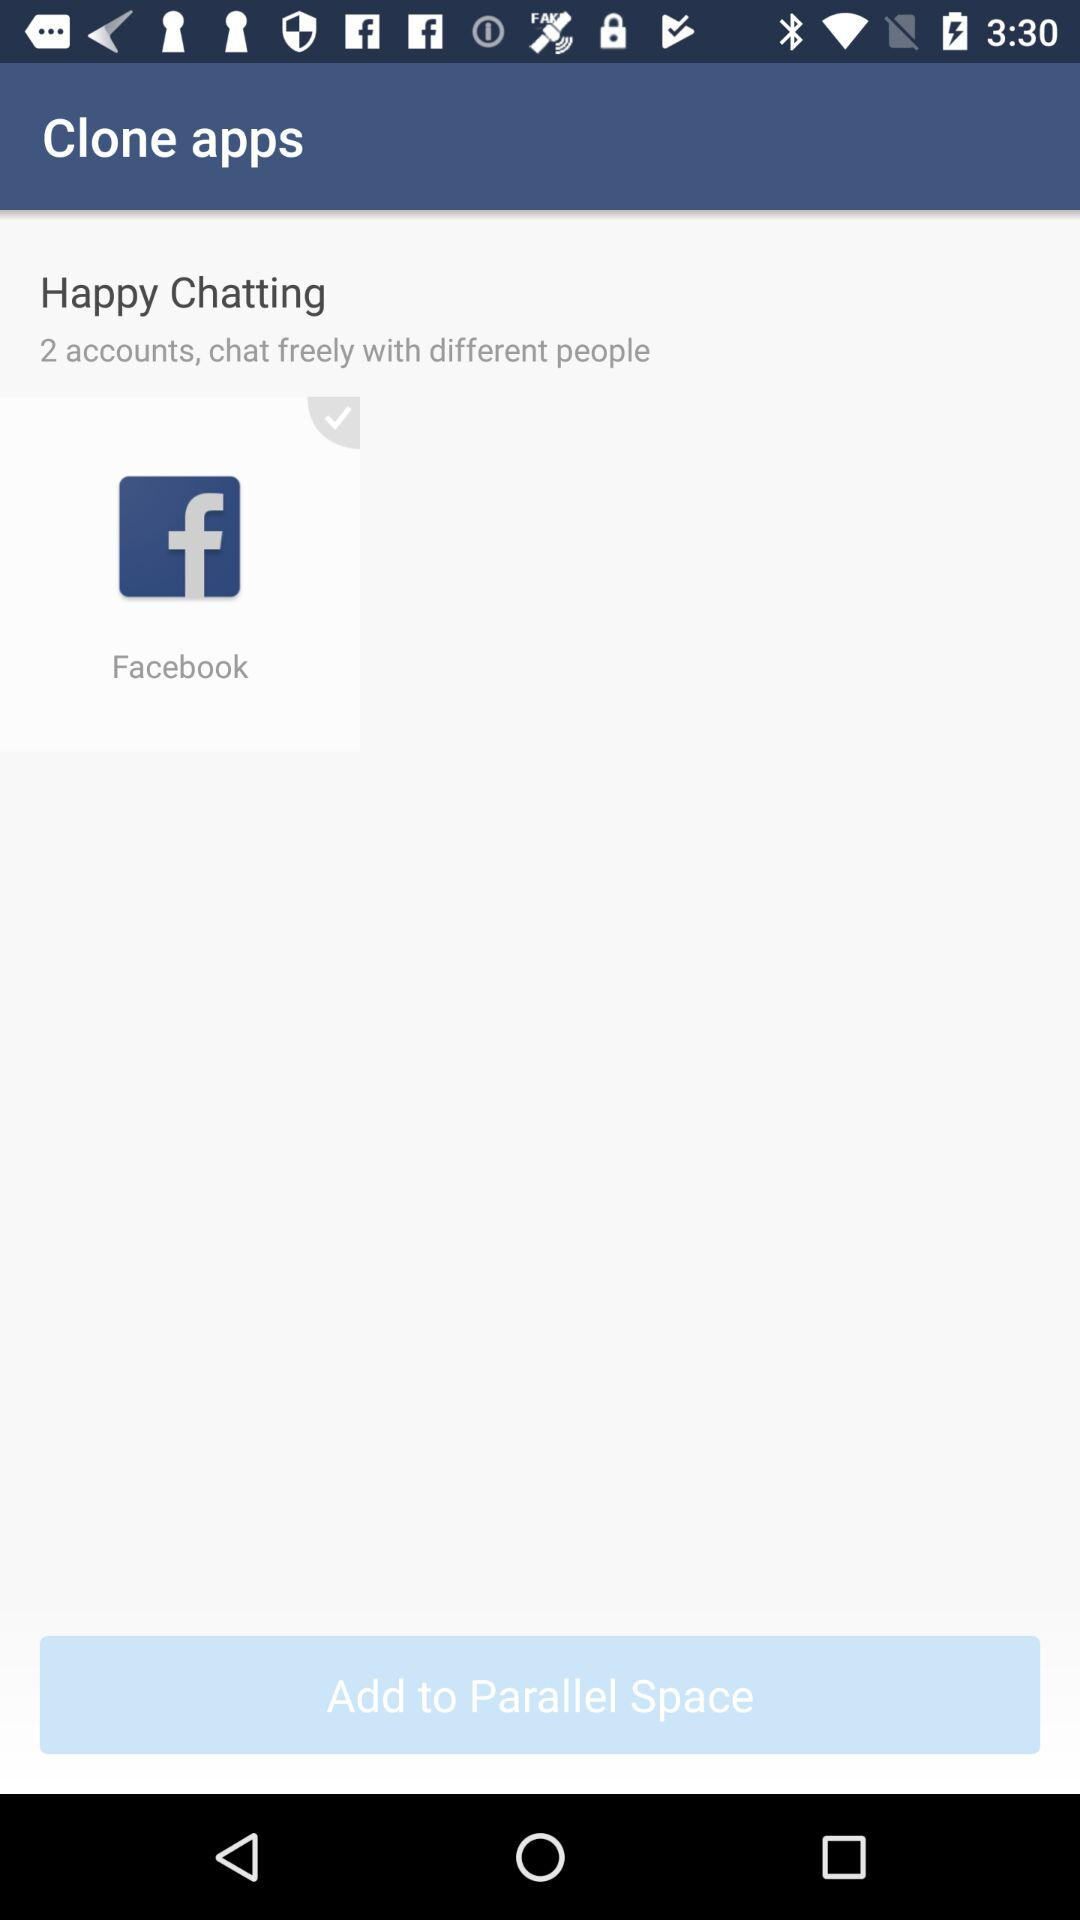How many cloned accounts can be used to chat freely with different people? There can be 2 cloned accounts to chat freely with different people. 